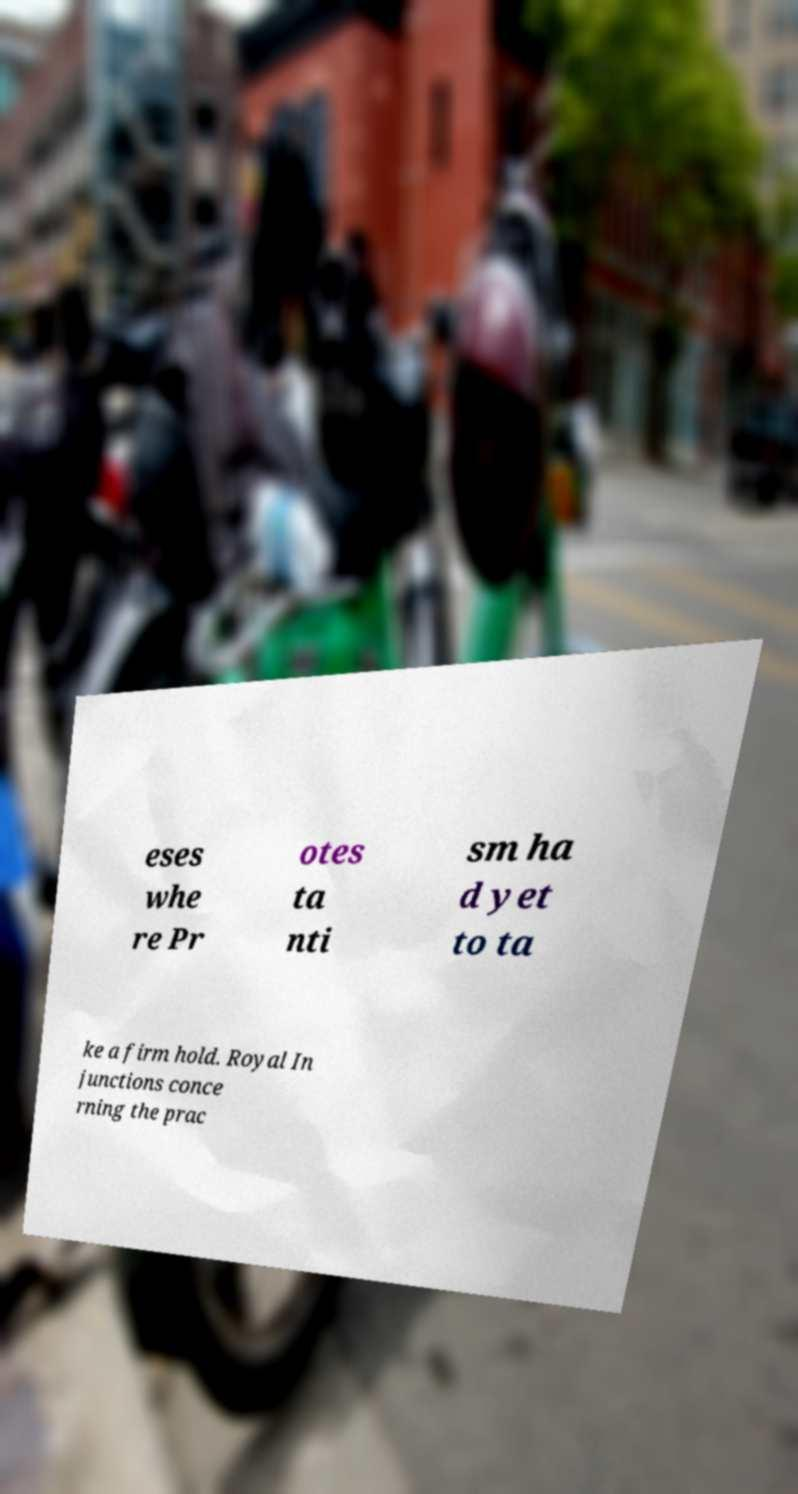Could you extract and type out the text from this image? eses whe re Pr otes ta nti sm ha d yet to ta ke a firm hold. Royal In junctions conce rning the prac 